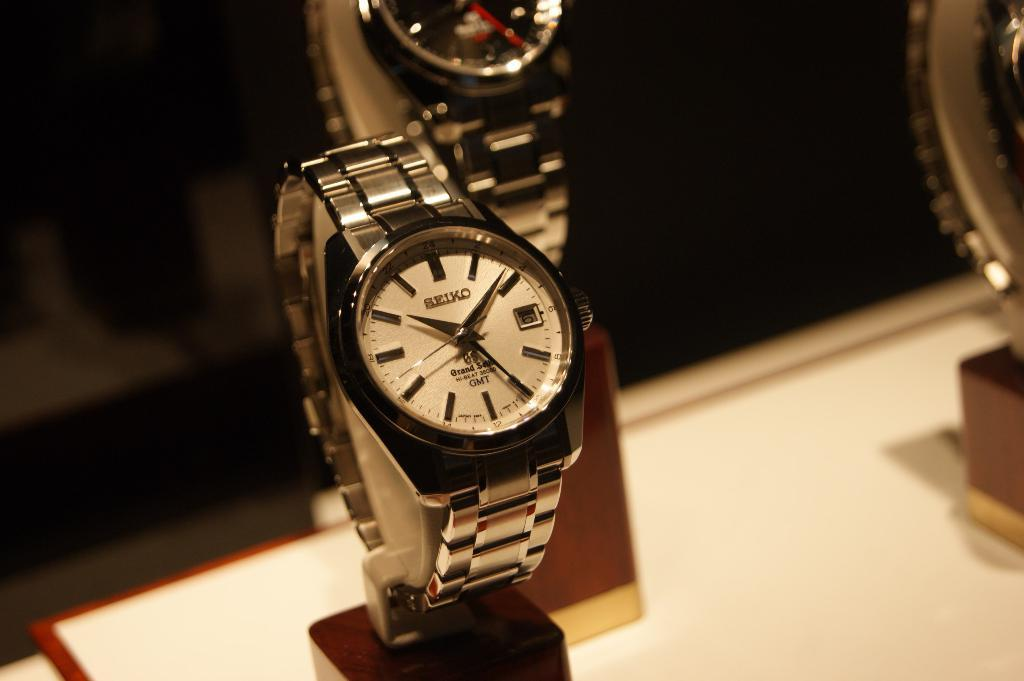<image>
Offer a succinct explanation of the picture presented. Wristwatch on display with the word SEIKO on the face. 